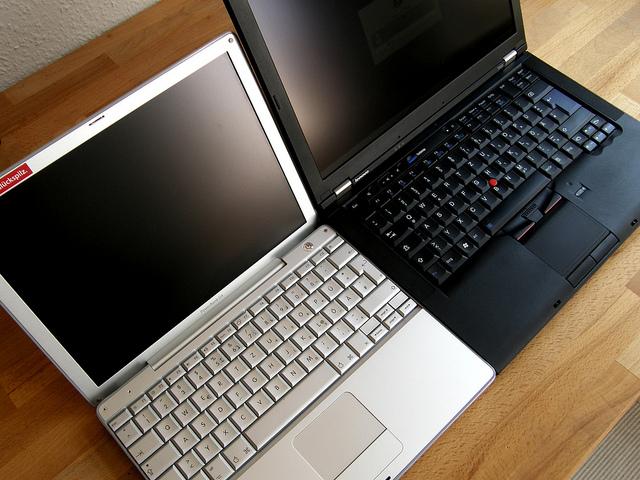What brand of computer is in this picture?
Short answer required. Dell. How many laptops are on the desk?
Concise answer only. 2. What colors are the laptops?
Give a very brief answer. Silver and black. Where is the desk made of?
Keep it brief. Wood. 